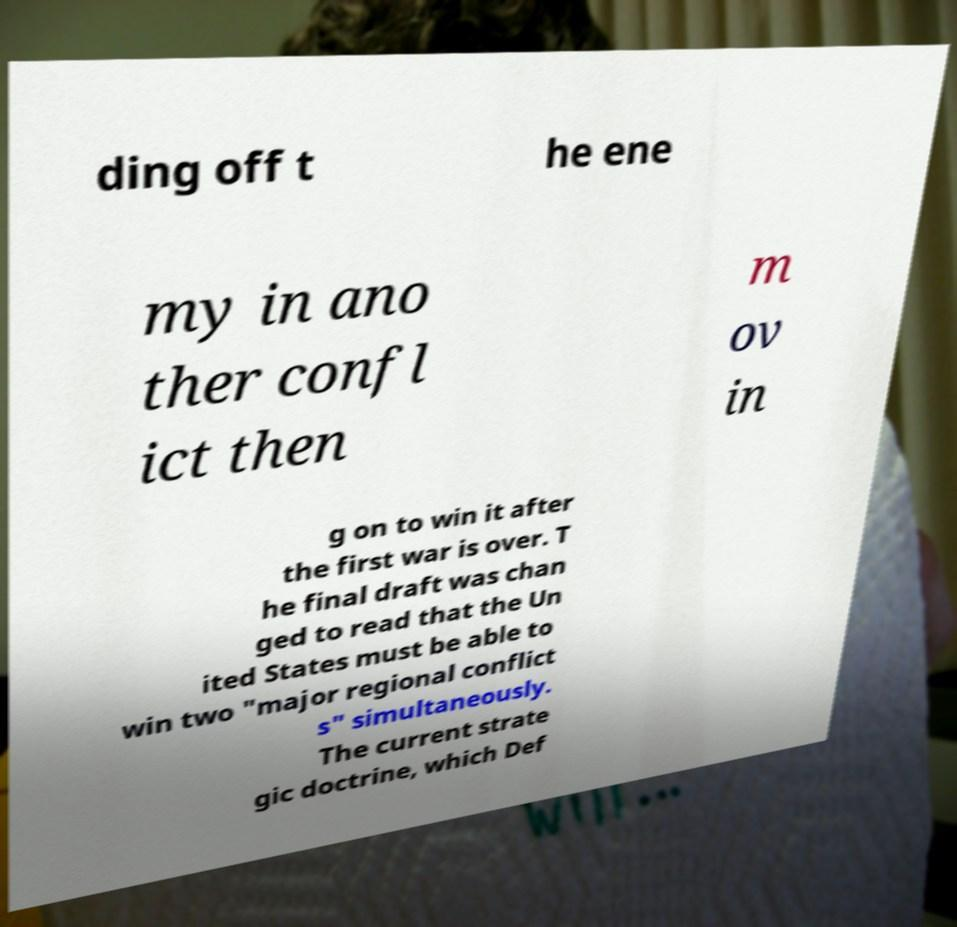Please read and relay the text visible in this image. What does it say? ding off t he ene my in ano ther confl ict then m ov in g on to win it after the first war is over. T he final draft was chan ged to read that the Un ited States must be able to win two "major regional conflict s" simultaneously. The current strate gic doctrine, which Def 